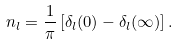<formula> <loc_0><loc_0><loc_500><loc_500>n _ { l } = \frac { 1 } { \pi } \left [ \delta _ { l } ( 0 ) - \delta _ { l } ( \infty ) \right ] .</formula> 